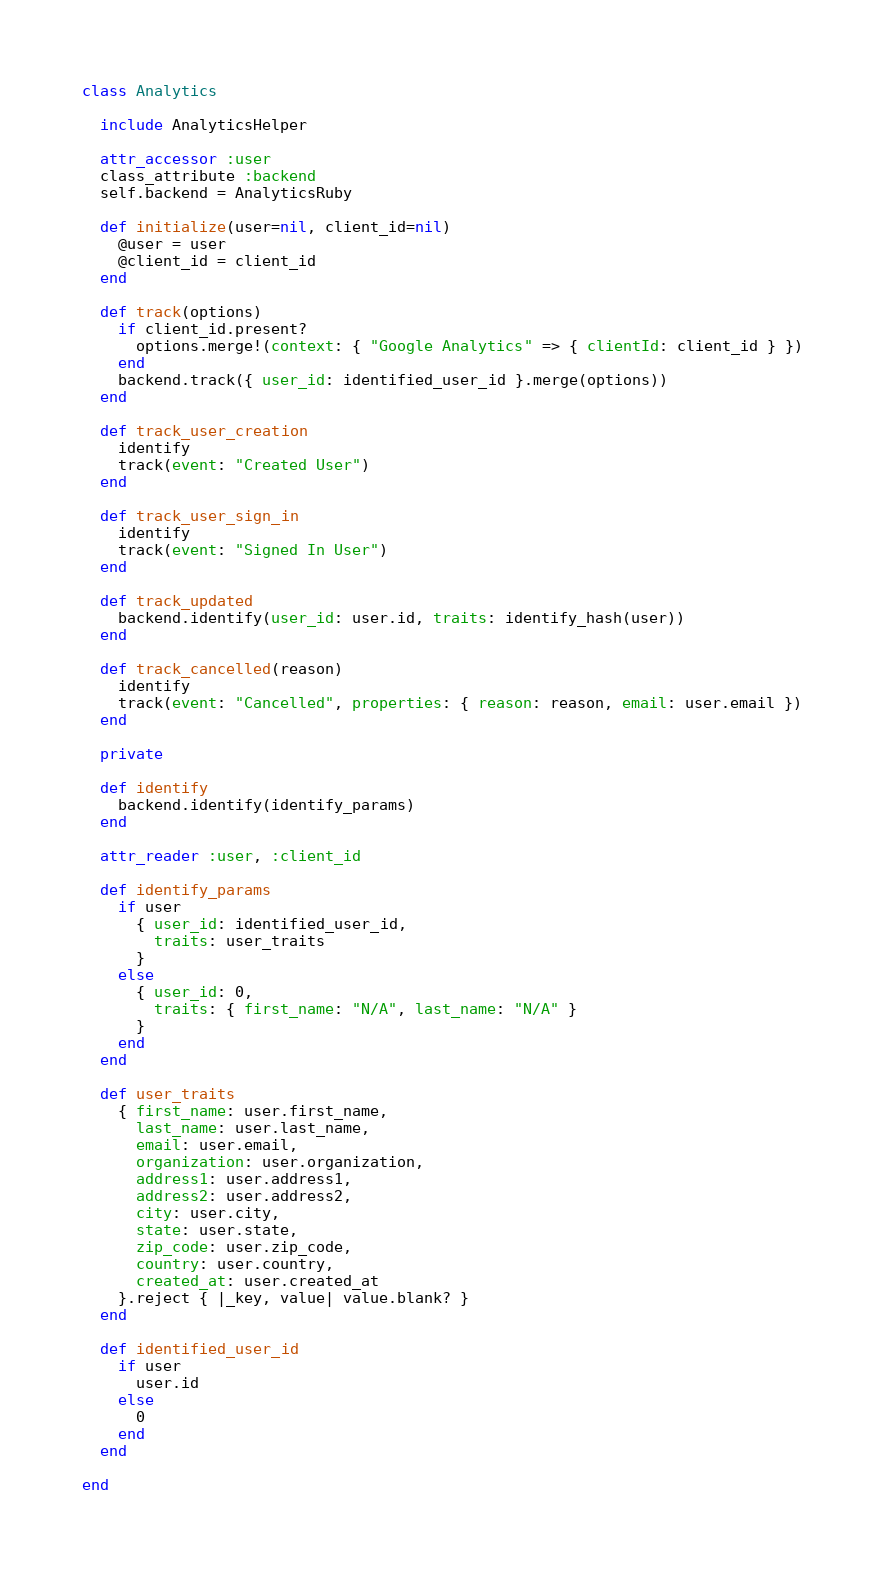Convert code to text. <code><loc_0><loc_0><loc_500><loc_500><_Ruby_>class Analytics

  include AnalyticsHelper

  attr_accessor :user
  class_attribute :backend
  self.backend = AnalyticsRuby

  def initialize(user=nil, client_id=nil)
    @user = user
    @client_id = client_id
  end

  def track(options)
    if client_id.present?
      options.merge!(context: { "Google Analytics" => { clientId: client_id } })
    end
    backend.track({ user_id: identified_user_id }.merge(options))
  end

  def track_user_creation
    identify
    track(event: "Created User")
  end

  def track_user_sign_in
    identify
    track(event: "Signed In User")
  end

  def track_updated
    backend.identify(user_id: user.id, traits: identify_hash(user))
  end

  def track_cancelled(reason)
    identify
    track(event: "Cancelled", properties: { reason: reason, email: user.email })
  end

  private

  def identify
    backend.identify(identify_params)
  end

  attr_reader :user, :client_id

  def identify_params
    if user
      { user_id: identified_user_id,
        traits: user_traits
      }
    else
      { user_id: 0,
        traits: { first_name: "N/A", last_name: "N/A" }
      }
    end
  end

  def user_traits
    { first_name: user.first_name,
      last_name: user.last_name,
      email: user.email,
      organization: user.organization,
      address1: user.address1,
      address2: user.address2,
      city: user.city,
      state: user.state,
      zip_code: user.zip_code,
      country: user.country,
      created_at: user.created_at
    }.reject { |_key, value| value.blank? }
  end

  def identified_user_id
    if user
      user.id
    else
      0
    end
  end

end
</code> 